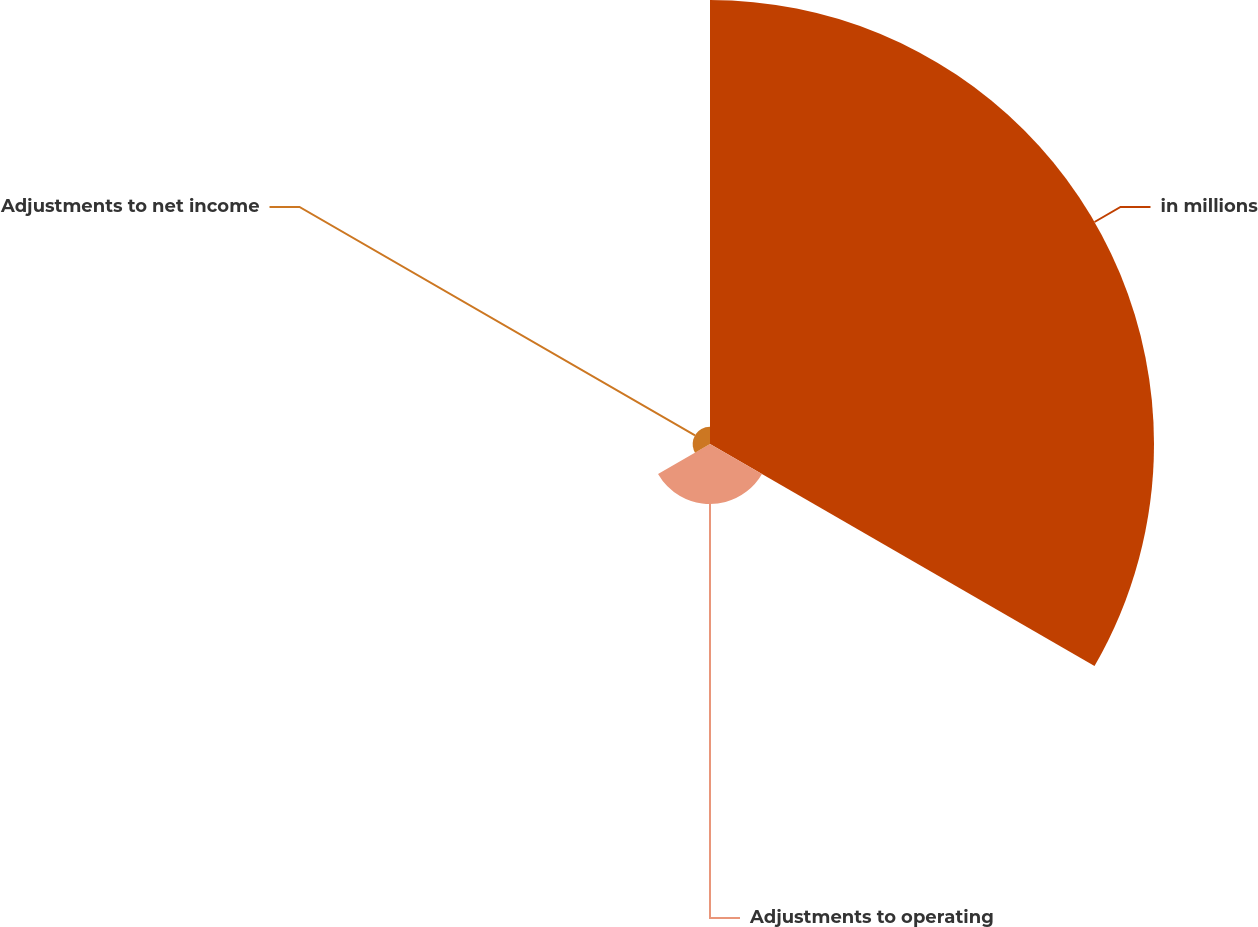Convert chart to OTSL. <chart><loc_0><loc_0><loc_500><loc_500><pie_chart><fcel>in millions<fcel>Adjustments to operating<fcel>Adjustments to net income<nl><fcel>85.17%<fcel>11.51%<fcel>3.32%<nl></chart> 